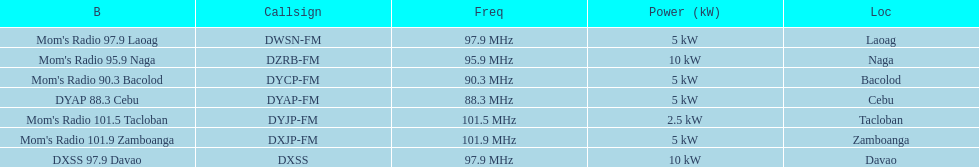How many kw was the radio in davao? 10 kW. 